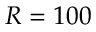<formula> <loc_0><loc_0><loc_500><loc_500>R = 1 0 0</formula> 